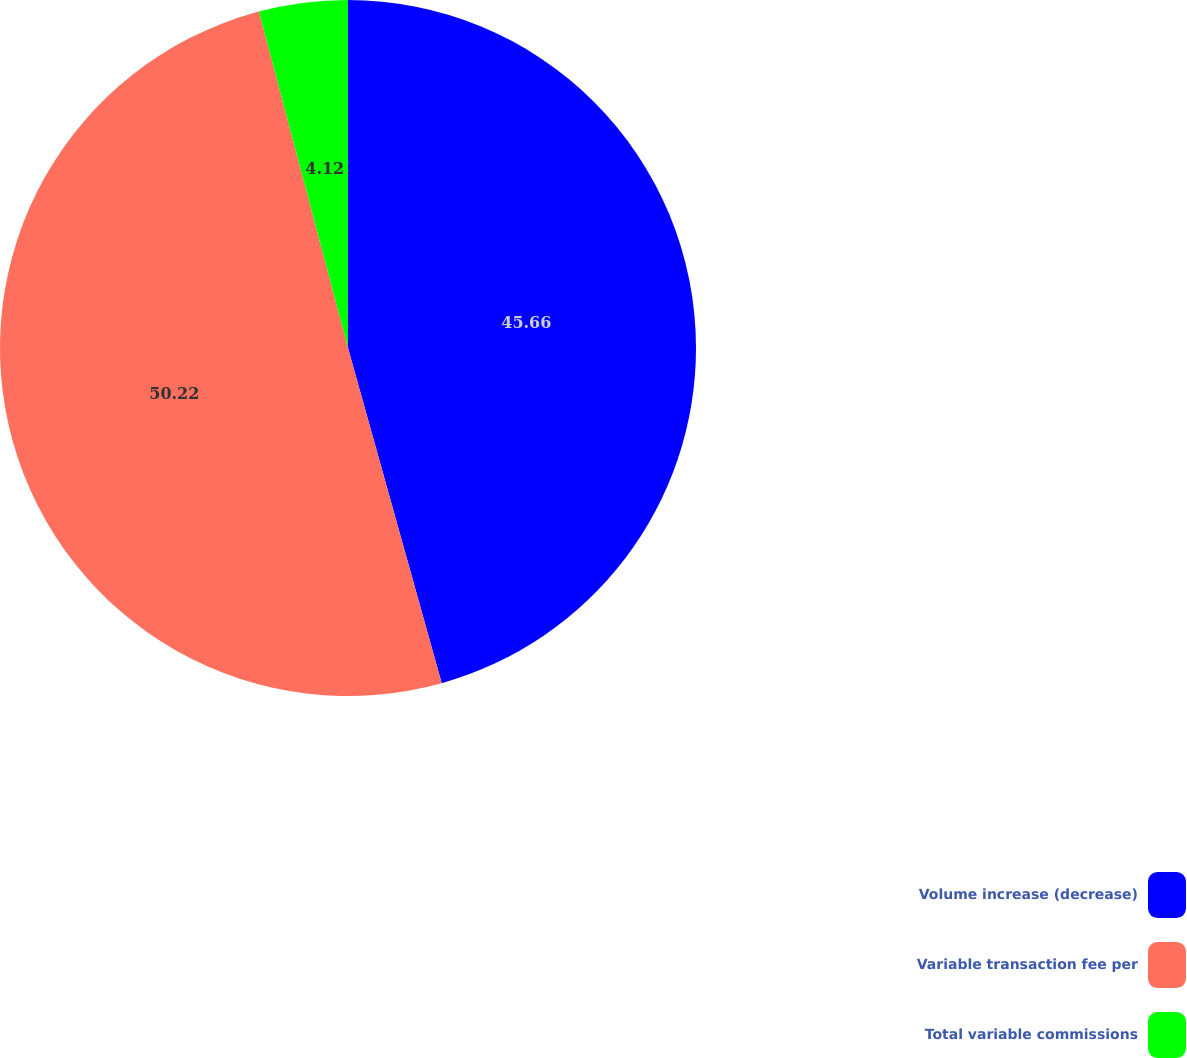Convert chart. <chart><loc_0><loc_0><loc_500><loc_500><pie_chart><fcel>Volume increase (decrease)<fcel>Variable transaction fee per<fcel>Total variable commissions<nl><fcel>45.66%<fcel>50.22%<fcel>4.12%<nl></chart> 